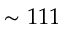Convert formula to latex. <formula><loc_0><loc_0><loc_500><loc_500>\sim 1 1 1</formula> 